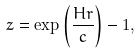<formula> <loc_0><loc_0><loc_500><loc_500>z = \exp \left ( \frac { H r } { c } \right ) - 1 ,</formula> 